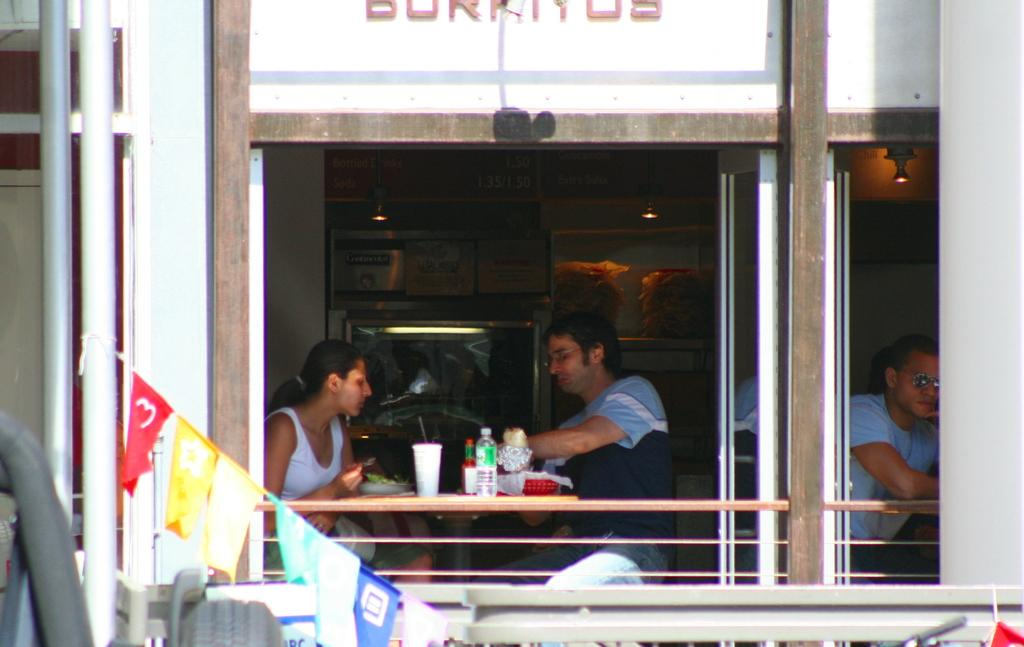What type of decorations can be seen in the image? There are decorative flags in the image. What structures are supporting the decorative flags? There are poles in the image. What are the people in the image doing? The people are sitting on chairs in the image. What piece of furniture is present in the image? There is a table in the image. What items are on the table? There are bottles and glasses in the image. What type of lighting is present in the image? There are lights in the image. What type of enclosure is present in the image? There are walls in the image. Can you describe any other objects in the image? There are some unspecified objects in the image. What type of rock is being used to settle an argument in the image? There is no rock or argument present in the image. How is the knot being used in the image? There is no knot present in the image. 